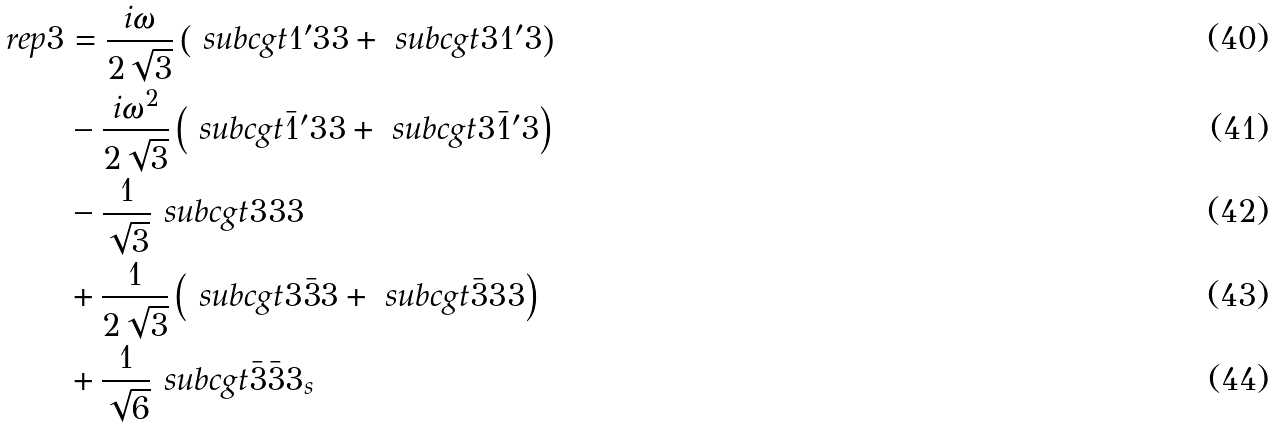Convert formula to latex. <formula><loc_0><loc_0><loc_500><loc_500>\ r e p { 3 } & = \frac { i \omega } { 2 \sqrt { 3 } } \left ( \ s u b c g t { 1 ^ { \prime } } { 3 } { 3 } + \ s u b c g t { 3 } { 1 ^ { \prime } } { 3 } \right ) \\ & - \frac { i \omega ^ { 2 } } { 2 \sqrt { 3 } } \left ( \ s u b c g t { \bar { 1 } ^ { \prime } } { 3 } { 3 } + \ s u b c g t { 3 } { \bar { 1 } ^ { \prime } } { 3 } \right ) \\ & - \frac { 1 } { \sqrt { 3 } } \ s u b c g t { 3 } { 3 } { 3 } \\ & + \frac { 1 } { 2 \sqrt { 3 } } \left ( \ s u b c g t { 3 } { \bar { 3 } } { 3 } + \ s u b c g t { \bar { 3 } } { 3 } { 3 } \right ) \\ & + \frac { 1 } { \sqrt { 6 } } \ s u b c g t { \bar { 3 } } { \bar { 3 } } { 3 _ { s } }</formula> 